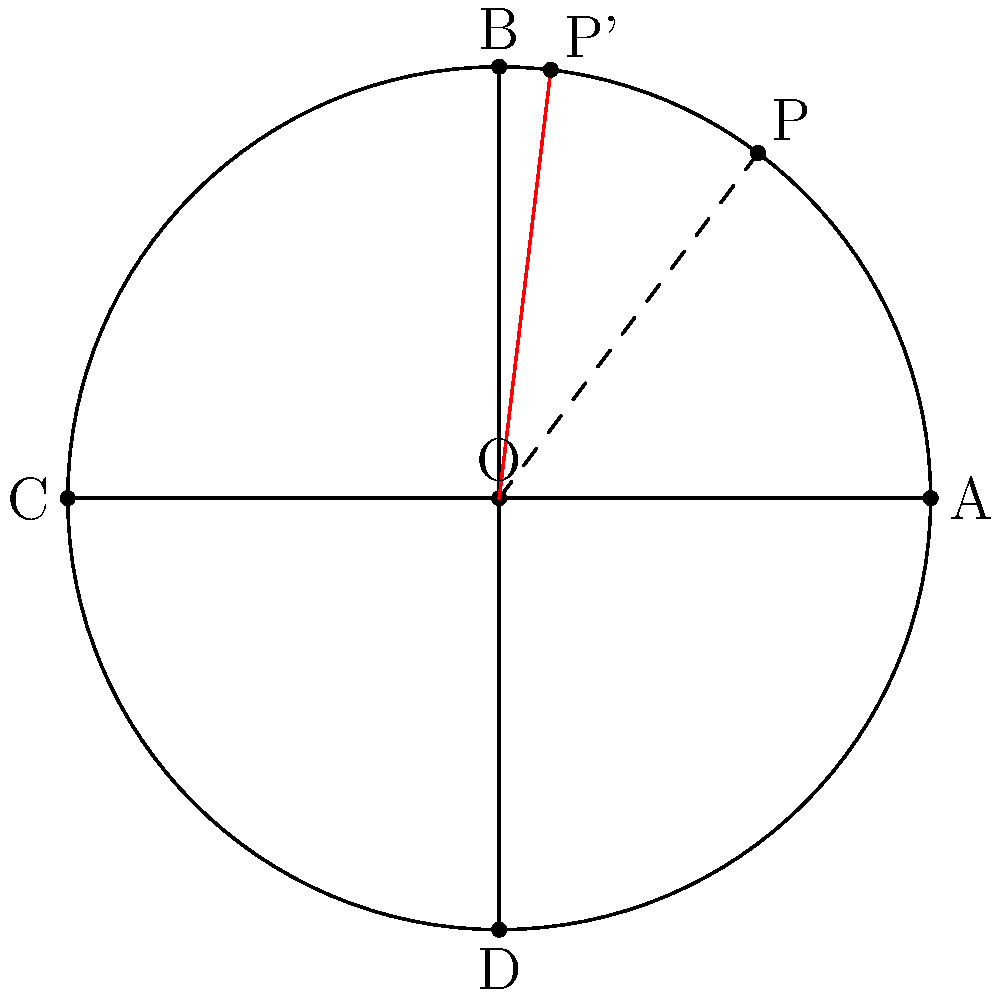In the basketball court diagram above, point P represents your favorite shooting position. To optimize your shooting angle, the court needs to be rotated 30° counterclockwise around the center O. What are the coordinates of your new shooting position P' after the rotation? To find the coordinates of P' after rotating P by 30° counterclockwise around O, we can follow these steps:

1. Identify the initial coordinates of P: (3, 4)

2. Use the rotation matrix for a counterclockwise rotation by θ:
   $$\begin{pmatrix} \cos θ & -\sin θ \\ \sin θ & \cos θ \end{pmatrix}$$

3. For θ = 30°, we have:
   $$\cos 30° = \frac{\sqrt{3}}{2} \approx 0.866$$
   $$\sin 30° = \frac{1}{2} = 0.5$$

4. Apply the rotation matrix to the coordinates of P:
   $$\begin{pmatrix} \cos 30° & -\sin 30° \\ \sin 30° & \cos 30° \end{pmatrix} \begin{pmatrix} 3 \\ 4 \end{pmatrix}$$

5. Calculate:
   $$\begin{pmatrix} 0.866 & -0.5 \\ 0.5 & 0.866 \end{pmatrix} \begin{pmatrix} 3 \\ 4 \end{pmatrix}$$
   
   $$= \begin{pmatrix} (0.866 \times 3) + (-0.5 \times 4) \\ (0.5 \times 3) + (0.866 \times 4) \end{pmatrix}$$
   
   $$= \begin{pmatrix} 2.598 - 2 \\ 1.5 + 3.464 \end{pmatrix}$$
   
   $$= \begin{pmatrix} 0.598 \\ 4.964 \end{pmatrix}$$

6. Round to two decimal places:
   P' ≈ (0.60, 4.96)

Therefore, after rotating the court 30° counterclockwise, your new shooting position P' will have coordinates approximately (0.60, 4.96).
Answer: (0.60, 4.96) 